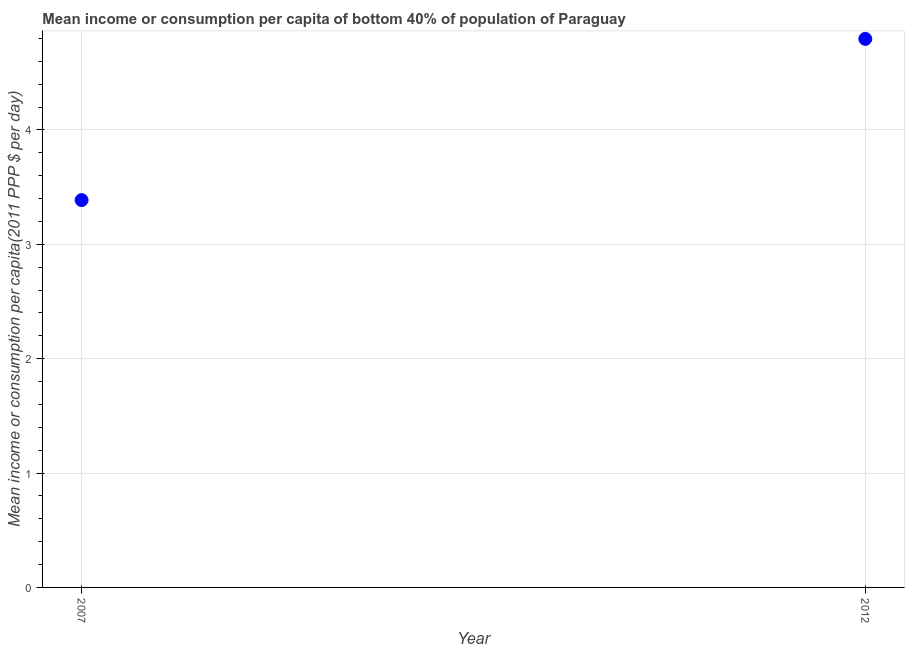What is the mean income or consumption in 2012?
Ensure brevity in your answer.  4.8. Across all years, what is the maximum mean income or consumption?
Your response must be concise. 4.8. Across all years, what is the minimum mean income or consumption?
Your response must be concise. 3.39. In which year was the mean income or consumption maximum?
Your answer should be very brief. 2012. In which year was the mean income or consumption minimum?
Provide a short and direct response. 2007. What is the sum of the mean income or consumption?
Provide a succinct answer. 8.18. What is the difference between the mean income or consumption in 2007 and 2012?
Your answer should be very brief. -1.41. What is the average mean income or consumption per year?
Offer a very short reply. 4.09. What is the median mean income or consumption?
Provide a succinct answer. 4.09. In how many years, is the mean income or consumption greater than 1.6 $?
Your response must be concise. 2. What is the ratio of the mean income or consumption in 2007 to that in 2012?
Ensure brevity in your answer.  0.71. Is the mean income or consumption in 2007 less than that in 2012?
Keep it short and to the point. Yes. Does the mean income or consumption monotonically increase over the years?
Your answer should be very brief. Yes. How many years are there in the graph?
Keep it short and to the point. 2. What is the difference between two consecutive major ticks on the Y-axis?
Your response must be concise. 1. What is the title of the graph?
Provide a short and direct response. Mean income or consumption per capita of bottom 40% of population of Paraguay. What is the label or title of the X-axis?
Your answer should be very brief. Year. What is the label or title of the Y-axis?
Your answer should be compact. Mean income or consumption per capita(2011 PPP $ per day). What is the Mean income or consumption per capita(2011 PPP $ per day) in 2007?
Offer a terse response. 3.39. What is the Mean income or consumption per capita(2011 PPP $ per day) in 2012?
Offer a very short reply. 4.8. What is the difference between the Mean income or consumption per capita(2011 PPP $ per day) in 2007 and 2012?
Offer a very short reply. -1.41. What is the ratio of the Mean income or consumption per capita(2011 PPP $ per day) in 2007 to that in 2012?
Provide a succinct answer. 0.71. 